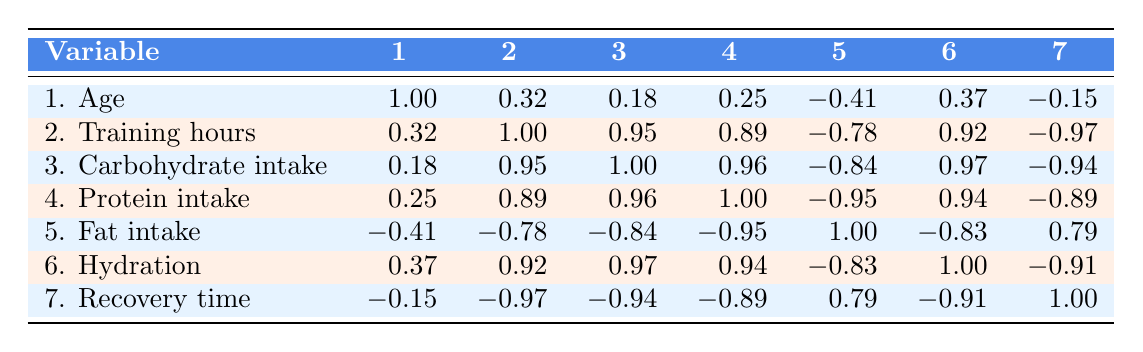What is the recovery time for David Brown? According to the table, David Brown's recovery time is listed under the recovery time row, which shows 20 hours as his value.
Answer: 20 hours What is the correlation between carbohydrate intake and recovery time? Looking at the table, the value in the table correlating carbohydrate intake (row 3) and recovery time (row 7) is -0.94, indicating a strong negative correlation.
Answer: -0.94 Who has the highest protein intake? By examining the protein intake values, David Brown has the highest intake with 150 grams per day, as seen in row 4.
Answer: David Brown Is there a correlation between hydration and recovery time? The correlation between hydration (row 6) and recovery time (row 7) is -0.91, which confirms a strong negative correlation.
Answer: Yes What is the average carbohydrate intake among the rowers? The carbohydrate intakes are 350, 400, 300, 450, and 320 grams. Summing these gives us 1820 grams; dividing by 5 provides an average of 364 grams.
Answer: 364 grams What is the difference in recovery time between Emily Johnson and Sarah Lee? Emily’s recovery time is 24 hours and Sarah's is 30 hours. The difference is calculated as 30 - 24 = 6 hours.
Answer: 6 hours Which rower has the lowest training hours per week? From the training hours provided, Sarah Lee has the lowest at 8 hours, which can be checked in row 2.
Answer: Sarah Lee Is it true that increasing training hours correlates positively with carbohydrate intake? The correlation between training hours (row 2) and carbohydrate intake (row 3) is 0.95, indicating a strong positive correlation. Therefore, the statement is true.
Answer: Yes 